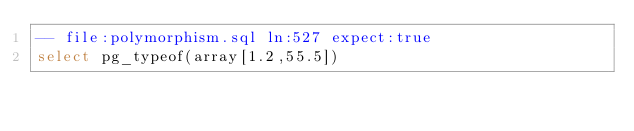<code> <loc_0><loc_0><loc_500><loc_500><_SQL_>-- file:polymorphism.sql ln:527 expect:true
select pg_typeof(array[1.2,55.5])
</code> 